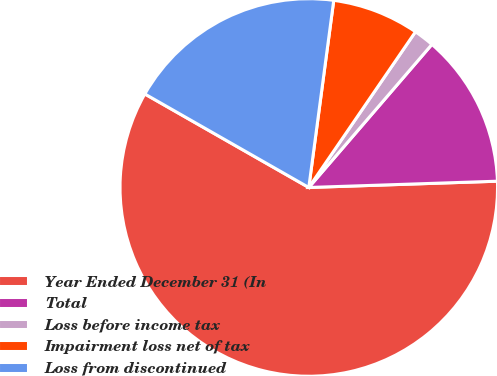<chart> <loc_0><loc_0><loc_500><loc_500><pie_chart><fcel>Year Ended December 31 (In<fcel>Total<fcel>Loss before income tax<fcel>Impairment loss net of tax<fcel>Loss from discontinued<nl><fcel>58.78%<fcel>13.16%<fcel>1.75%<fcel>7.45%<fcel>18.86%<nl></chart> 